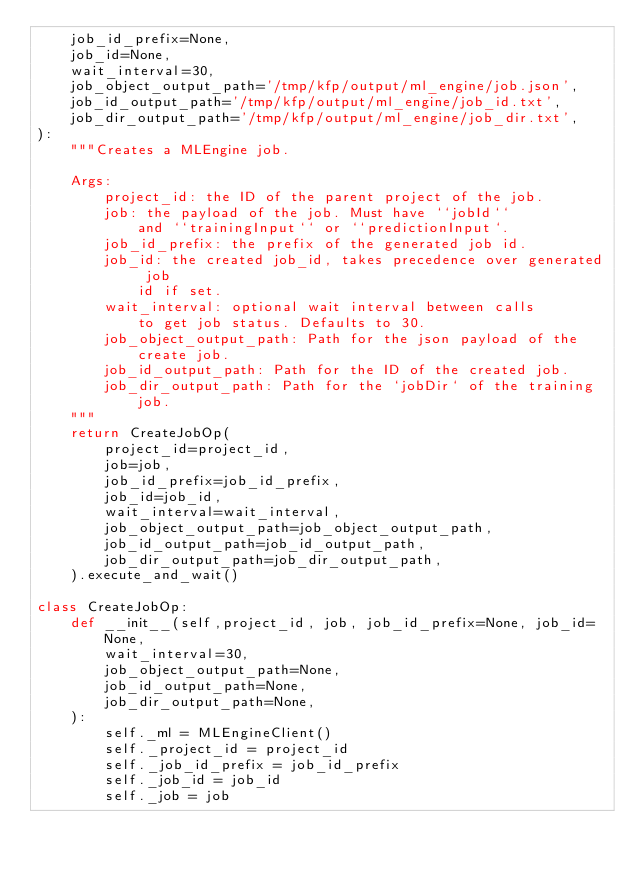<code> <loc_0><loc_0><loc_500><loc_500><_Python_>    job_id_prefix=None,
    job_id=None,
    wait_interval=30,
    job_object_output_path='/tmp/kfp/output/ml_engine/job.json',
    job_id_output_path='/tmp/kfp/output/ml_engine/job_id.txt',
    job_dir_output_path='/tmp/kfp/output/ml_engine/job_dir.txt',
):
    """Creates a MLEngine job.

    Args:
        project_id: the ID of the parent project of the job.
        job: the payload of the job. Must have ``jobId`` 
            and ``trainingInput`` or ``predictionInput`.
        job_id_prefix: the prefix of the generated job id.
        job_id: the created job_id, takes precedence over generated job
            id if set.
        wait_interval: optional wait interval between calls
            to get job status. Defaults to 30.
        job_object_output_path: Path for the json payload of the create job.
        job_id_output_path: Path for the ID of the created job.
        job_dir_output_path: Path for the `jobDir` of the training job.
    """
    return CreateJobOp(
        project_id=project_id,
        job=job,
        job_id_prefix=job_id_prefix,
        job_id=job_id,
        wait_interval=wait_interval,
        job_object_output_path=job_object_output_path,
        job_id_output_path=job_id_output_path,
        job_dir_output_path=job_dir_output_path,
    ).execute_and_wait()

class CreateJobOp:
    def __init__(self,project_id, job, job_id_prefix=None, job_id=None,
        wait_interval=30,
        job_object_output_path=None,
        job_id_output_path=None,
        job_dir_output_path=None,
    ):
        self._ml = MLEngineClient()
        self._project_id = project_id
        self._job_id_prefix = job_id_prefix
        self._job_id = job_id
        self._job = job</code> 